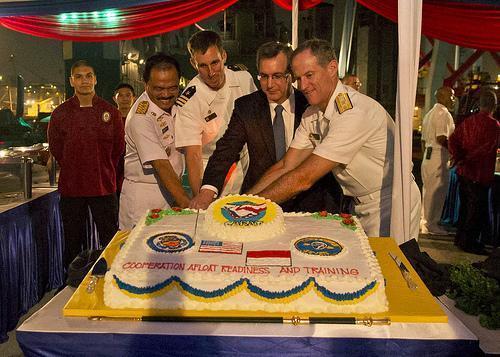How many men are cutting the cake?
Give a very brief answer. 4. How many men are wearing a brown suit?
Give a very brief answer. 1. How many men are dressed in white uniforms and cutting the cake?
Give a very brief answer. 3. How many men are ready to cut the cake?
Give a very brief answer. 4. 